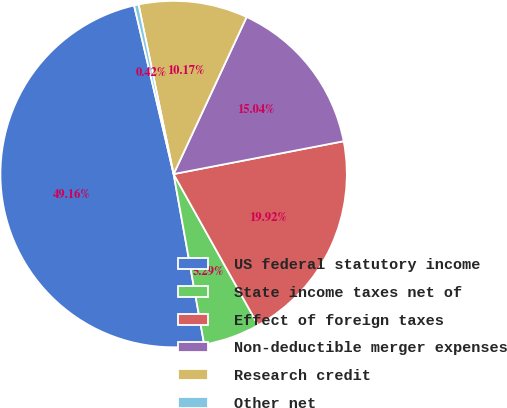Convert chart to OTSL. <chart><loc_0><loc_0><loc_500><loc_500><pie_chart><fcel>US federal statutory income<fcel>State income taxes net of<fcel>Effect of foreign taxes<fcel>Non-deductible merger expenses<fcel>Research credit<fcel>Other net<nl><fcel>49.16%<fcel>5.29%<fcel>19.92%<fcel>15.04%<fcel>10.17%<fcel>0.42%<nl></chart> 